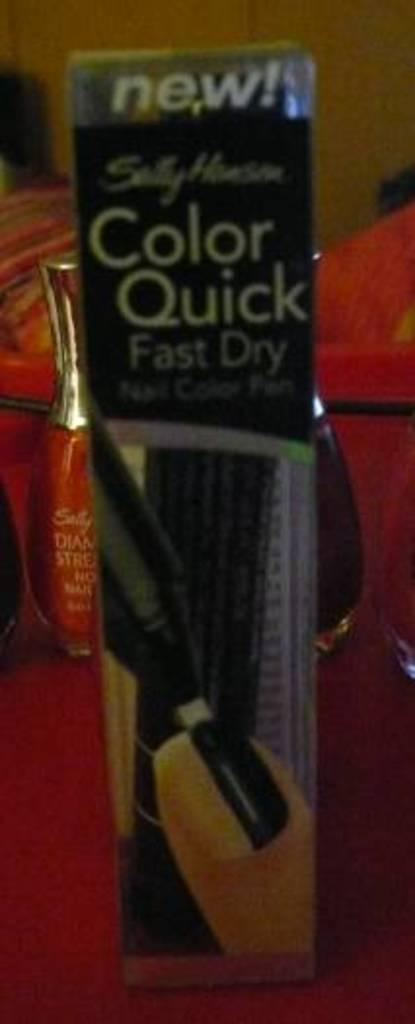<image>
Give a short and clear explanation of the subsequent image. A red bottle of nail polish is hidden behind a new product that claims to be color quick and fast dry. 